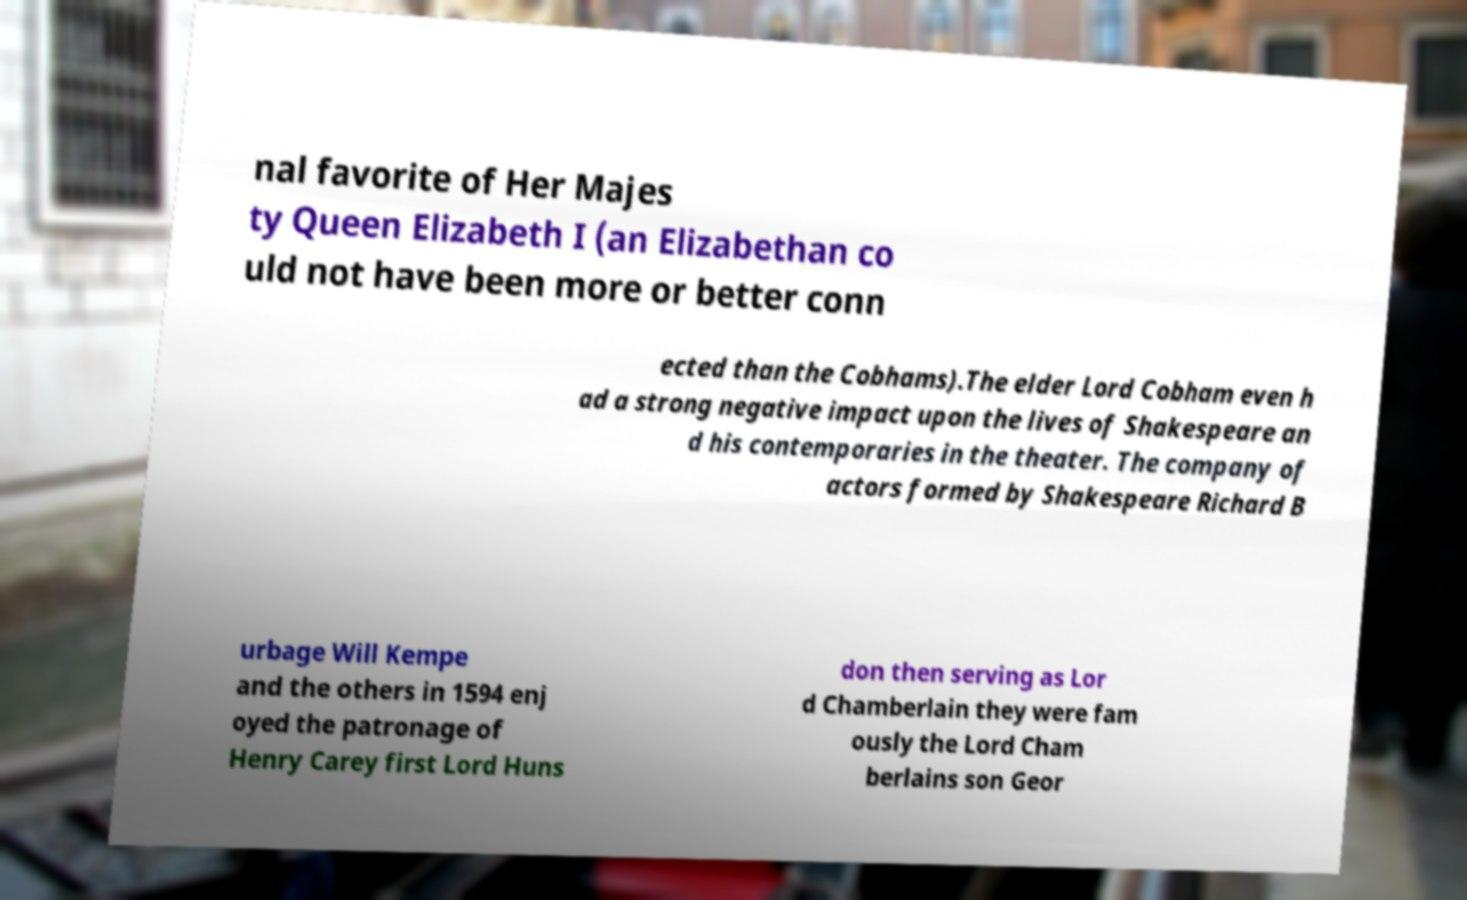Can you accurately transcribe the text from the provided image for me? nal favorite of Her Majes ty Queen Elizabeth I (an Elizabethan co uld not have been more or better conn ected than the Cobhams).The elder Lord Cobham even h ad a strong negative impact upon the lives of Shakespeare an d his contemporaries in the theater. The company of actors formed by Shakespeare Richard B urbage Will Kempe and the others in 1594 enj oyed the patronage of Henry Carey first Lord Huns don then serving as Lor d Chamberlain they were fam ously the Lord Cham berlains son Geor 